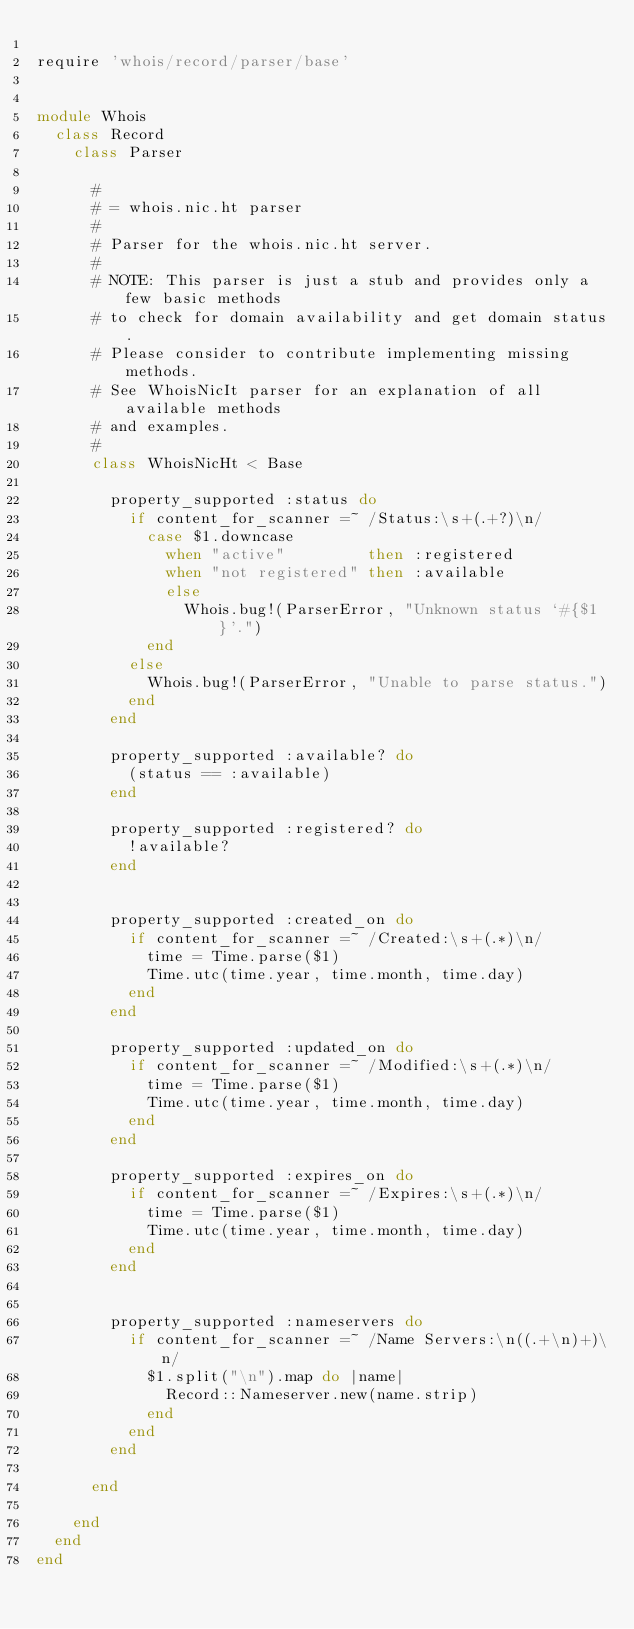<code> <loc_0><loc_0><loc_500><loc_500><_Ruby_>
require 'whois/record/parser/base'


module Whois
  class Record
    class Parser

      #
      # = whois.nic.ht parser
      #
      # Parser for the whois.nic.ht server.
      #
      # NOTE: This parser is just a stub and provides only a few basic methods
      # to check for domain availability and get domain status.
      # Please consider to contribute implementing missing methods.
      # See WhoisNicIt parser for an explanation of all available methods
      # and examples.
      #
      class WhoisNicHt < Base

        property_supported :status do
          if content_for_scanner =~ /Status:\s+(.+?)\n/
            case $1.downcase
              when "active"         then :registered
              when "not registered" then :available
              else
                Whois.bug!(ParserError, "Unknown status `#{$1}'.")
            end
          else
            Whois.bug!(ParserError, "Unable to parse status.")
          end
        end

        property_supported :available? do
          (status == :available)
        end

        property_supported :registered? do
          !available?
        end


        property_supported :created_on do
          if content_for_scanner =~ /Created:\s+(.*)\n/
            time = Time.parse($1)
            Time.utc(time.year, time.month, time.day)
          end
        end

        property_supported :updated_on do
          if content_for_scanner =~ /Modified:\s+(.*)\n/
            time = Time.parse($1)
            Time.utc(time.year, time.month, time.day)
          end
        end

        property_supported :expires_on do
          if content_for_scanner =~ /Expires:\s+(.*)\n/
            time = Time.parse($1)
            Time.utc(time.year, time.month, time.day)
          end
        end


        property_supported :nameservers do
          if content_for_scanner =~ /Name Servers:\n((.+\n)+)\n/
            $1.split("\n").map do |name|
              Record::Nameserver.new(name.strip)
            end
          end
        end

      end

    end
  end
end
</code> 